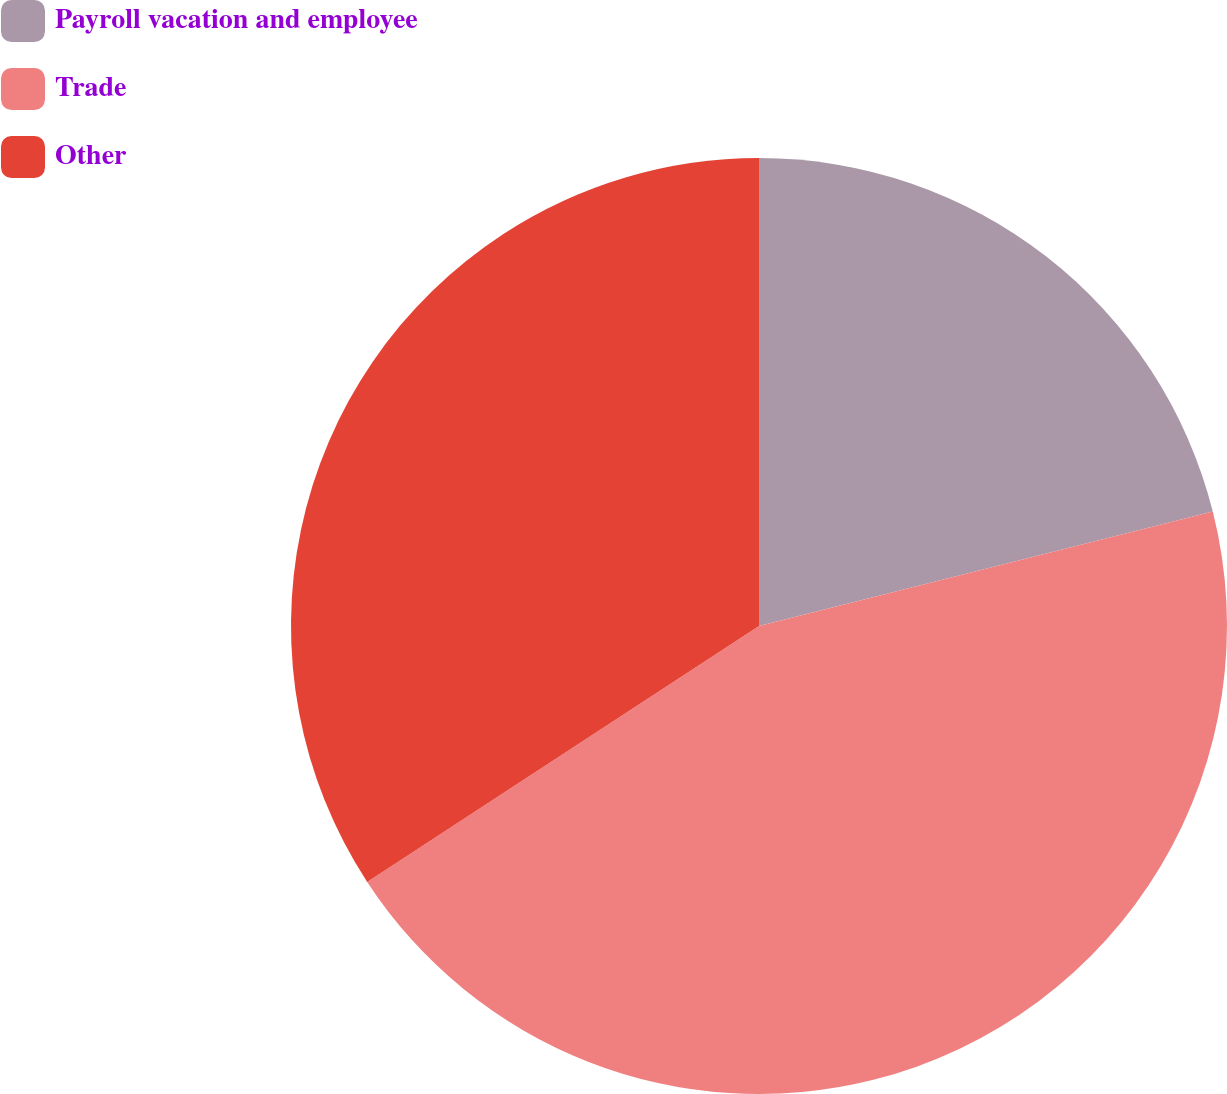<chart> <loc_0><loc_0><loc_500><loc_500><pie_chart><fcel>Payroll vacation and employee<fcel>Trade<fcel>Other<nl><fcel>21.07%<fcel>44.72%<fcel>34.21%<nl></chart> 